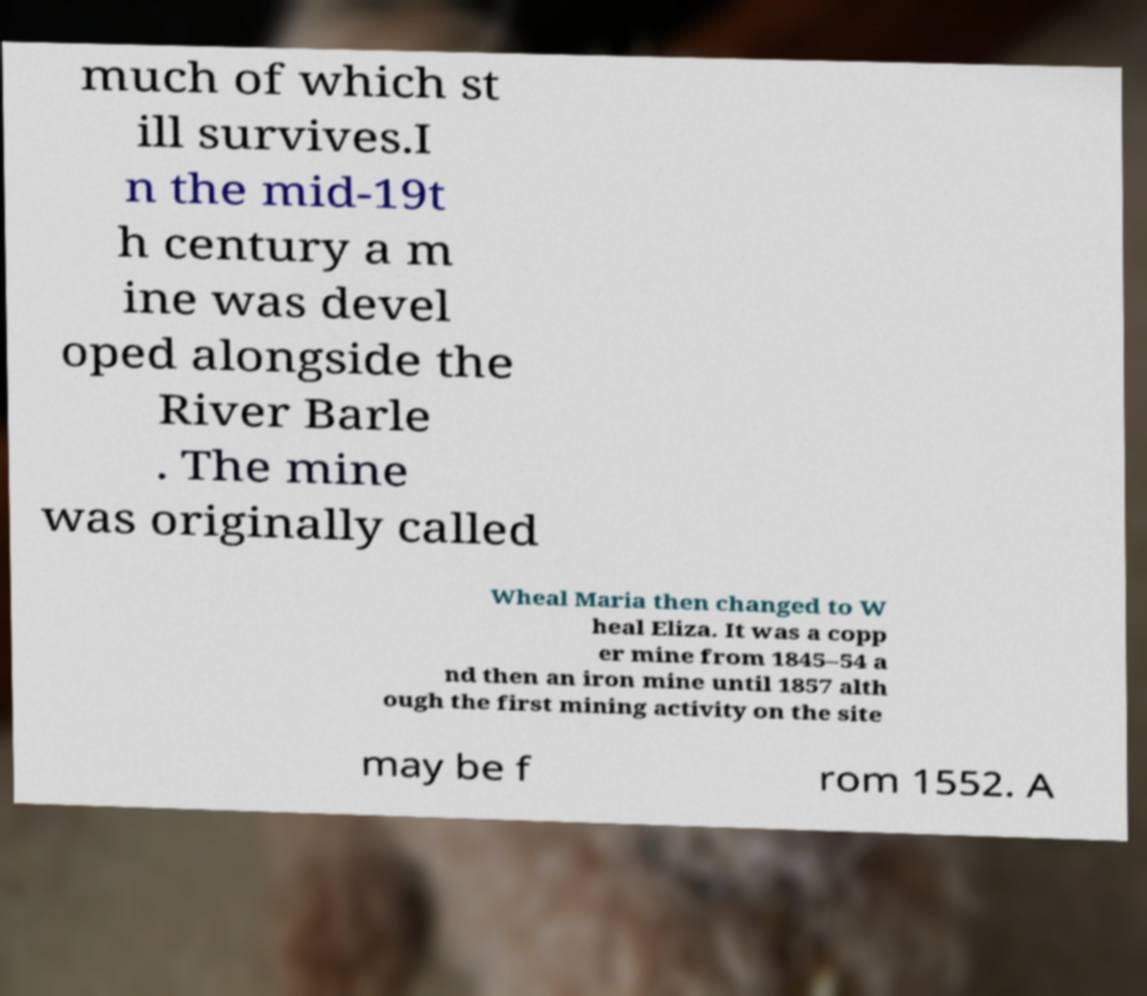Please read and relay the text visible in this image. What does it say? much of which st ill survives.I n the mid-19t h century a m ine was devel oped alongside the River Barle . The mine was originally called Wheal Maria then changed to W heal Eliza. It was a copp er mine from 1845–54 a nd then an iron mine until 1857 alth ough the first mining activity on the site may be f rom 1552. A 